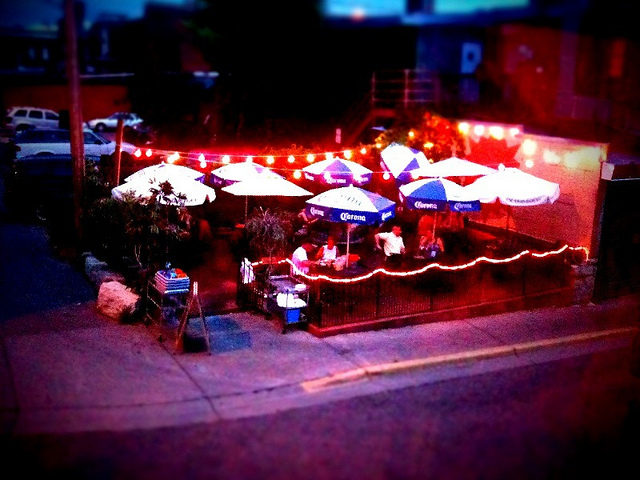<image>What shape do the lights make? I am not sure. The lights could form a triangle, squares, circles, or lines. What shape do the lights make? I am not sure what shape the lights make. It can be seen as a triangle, circles or a square. 